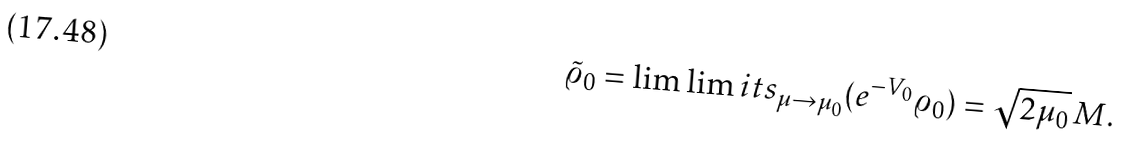<formula> <loc_0><loc_0><loc_500><loc_500>\tilde { \varrho } _ { 0 } = \lim \lim i t s _ { \mu \to \mu _ { 0 } } ( e ^ { - V _ { 0 } } \varrho _ { 0 } ) = \sqrt { 2 \mu _ { 0 } } \, M .</formula> 